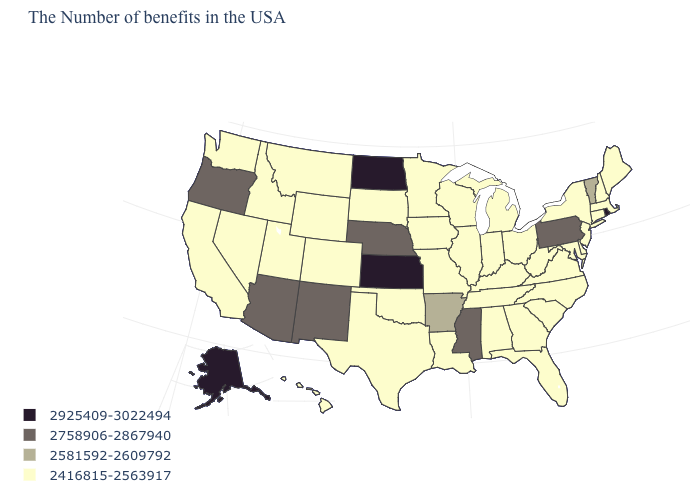Does Virginia have the lowest value in the South?
Keep it brief. Yes. What is the value of New York?
Keep it brief. 2416815-2563917. Name the states that have a value in the range 2416815-2563917?
Quick response, please. Maine, Massachusetts, New Hampshire, Connecticut, New York, New Jersey, Delaware, Maryland, Virginia, North Carolina, South Carolina, West Virginia, Ohio, Florida, Georgia, Michigan, Kentucky, Indiana, Alabama, Tennessee, Wisconsin, Illinois, Louisiana, Missouri, Minnesota, Iowa, Oklahoma, Texas, South Dakota, Wyoming, Colorado, Utah, Montana, Idaho, Nevada, California, Washington, Hawaii. Is the legend a continuous bar?
Keep it brief. No. Does the map have missing data?
Be succinct. No. What is the lowest value in the USA?
Keep it brief. 2416815-2563917. Name the states that have a value in the range 2581592-2609792?
Keep it brief. Vermont, Arkansas. What is the highest value in states that border Pennsylvania?
Give a very brief answer. 2416815-2563917. Name the states that have a value in the range 2416815-2563917?
Be succinct. Maine, Massachusetts, New Hampshire, Connecticut, New York, New Jersey, Delaware, Maryland, Virginia, North Carolina, South Carolina, West Virginia, Ohio, Florida, Georgia, Michigan, Kentucky, Indiana, Alabama, Tennessee, Wisconsin, Illinois, Louisiana, Missouri, Minnesota, Iowa, Oklahoma, Texas, South Dakota, Wyoming, Colorado, Utah, Montana, Idaho, Nevada, California, Washington, Hawaii. What is the value of Nebraska?
Keep it brief. 2758906-2867940. What is the value of Georgia?
Quick response, please. 2416815-2563917. What is the value of Utah?
Quick response, please. 2416815-2563917. Which states have the lowest value in the USA?
Answer briefly. Maine, Massachusetts, New Hampshire, Connecticut, New York, New Jersey, Delaware, Maryland, Virginia, North Carolina, South Carolina, West Virginia, Ohio, Florida, Georgia, Michigan, Kentucky, Indiana, Alabama, Tennessee, Wisconsin, Illinois, Louisiana, Missouri, Minnesota, Iowa, Oklahoma, Texas, South Dakota, Wyoming, Colorado, Utah, Montana, Idaho, Nevada, California, Washington, Hawaii. What is the value of Mississippi?
Concise answer only. 2758906-2867940. Name the states that have a value in the range 2925409-3022494?
Concise answer only. Rhode Island, Kansas, North Dakota, Alaska. 